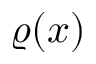Convert formula to latex. <formula><loc_0><loc_0><loc_500><loc_500>\varrho ( x )</formula> 